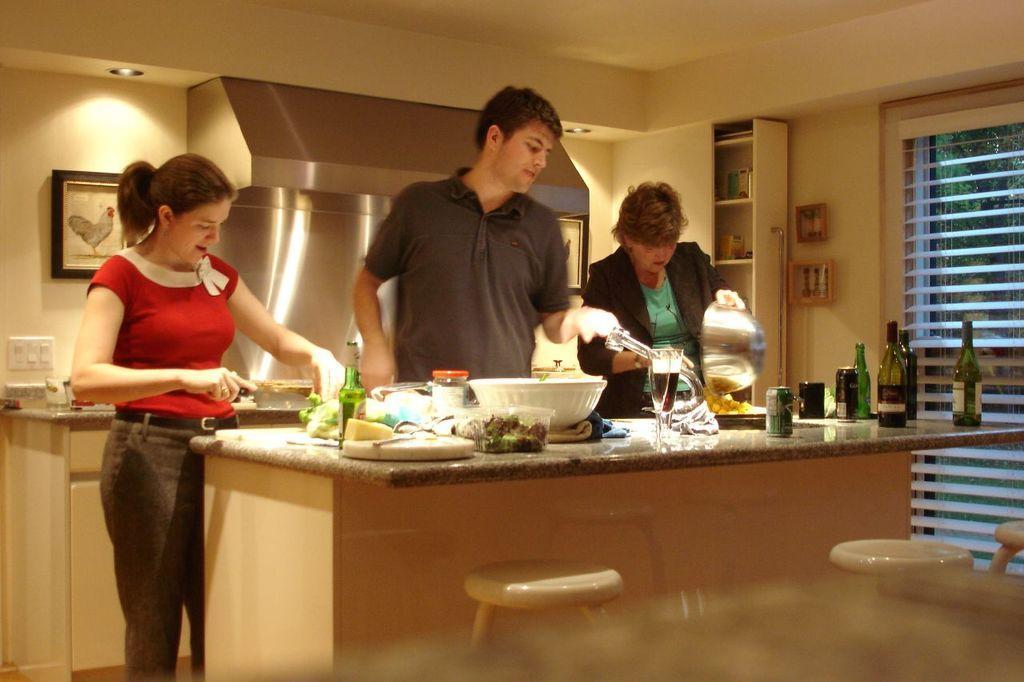Describe this image in one or two sentences. We can see frames over a wall. These are cupboards. This is a chimney. On the kitchen platform we can see bottles, containers, bowl, glasses with drinks in,tins. Here we can see a woman transferring food from one bowl to a plate. This woman is cutting vegetable with a knife. These are stools. This is a switch board. 